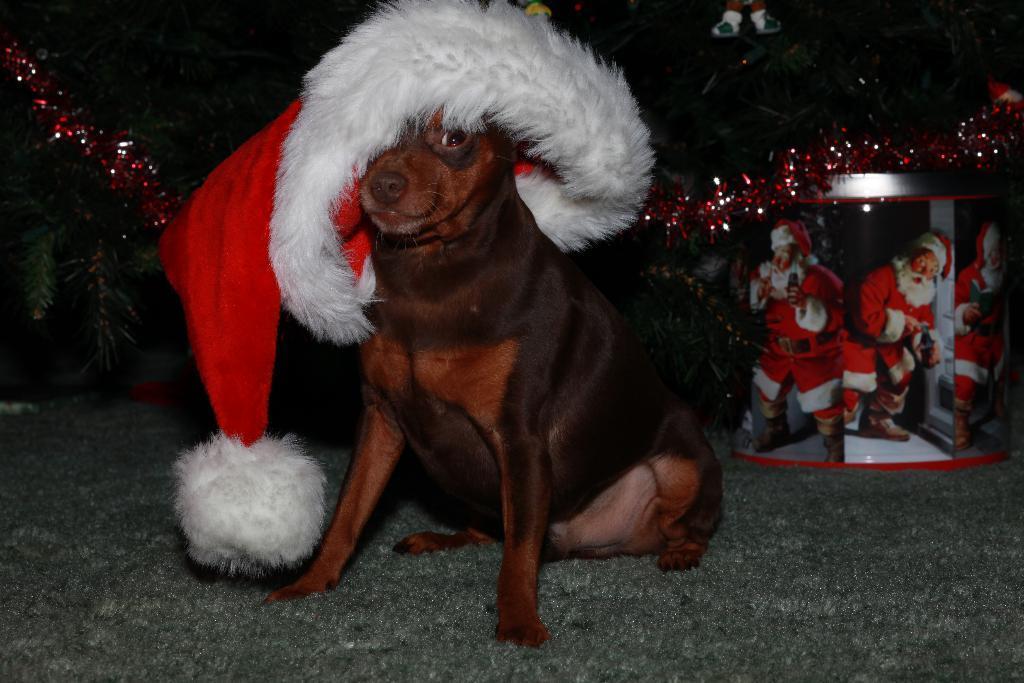In one or two sentences, can you explain what this image depicts? In the picture we can see a dog is sitting on the floor and the dog is brown in color and on it we can see a Santa Claus cap and behind the dog we can see a Santa Claus image and some decorations in the dark. 